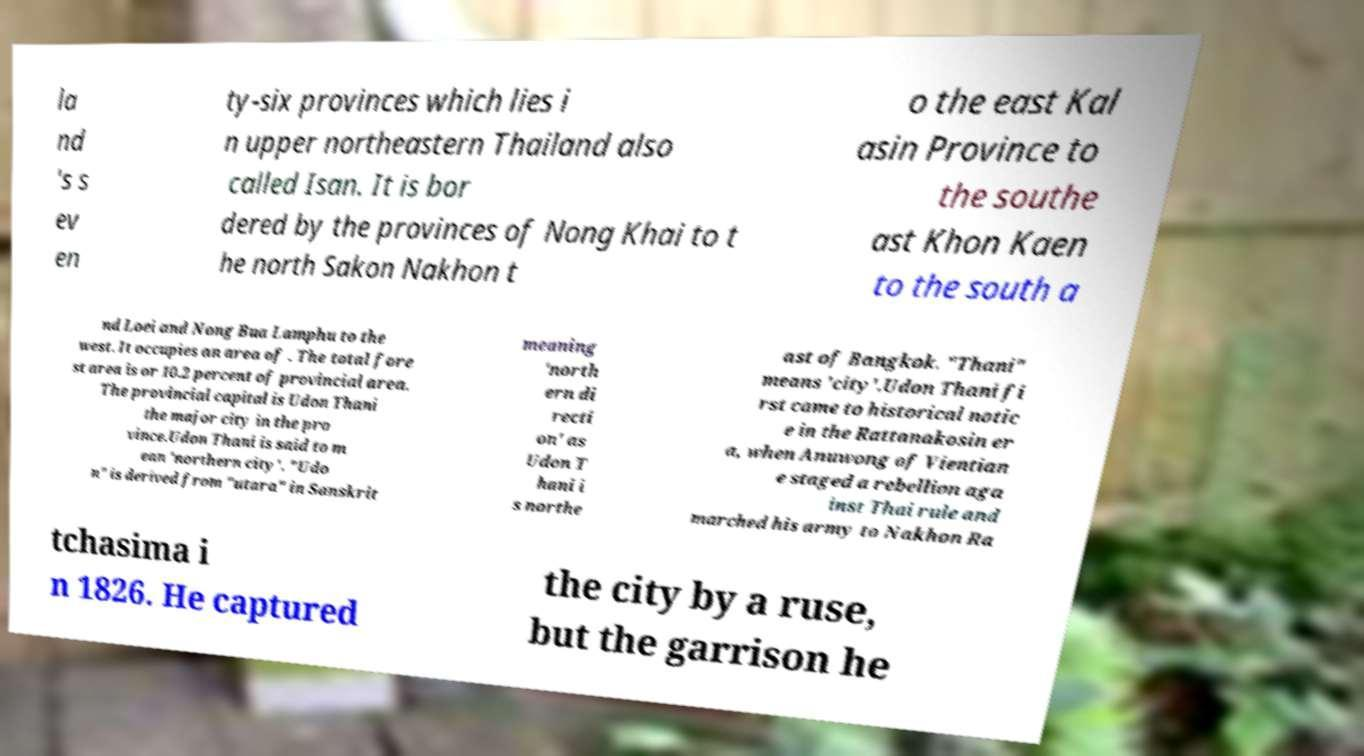What messages or text are displayed in this image? I need them in a readable, typed format. la nd 's s ev en ty-six provinces which lies i n upper northeastern Thailand also called Isan. It is bor dered by the provinces of Nong Khai to t he north Sakon Nakhon t o the east Kal asin Province to the southe ast Khon Kaen to the south a nd Loei and Nong Bua Lamphu to the west. It occupies an area of . The total fore st area is or 10.2 percent of provincial area. The provincial capital is Udon Thani the major city in the pro vince.Udon Thani is said to m ean 'northern city'. "Udo n" is derived from "utara" in Sanskrit meaning 'north ern di recti on' as Udon T hani i s northe ast of Bangkok. "Thani" means 'city'.Udon Thani fi rst came to historical notic e in the Rattanakosin er a, when Anuwong of Vientian e staged a rebellion aga inst Thai rule and marched his army to Nakhon Ra tchasima i n 1826. He captured the city by a ruse, but the garrison he 